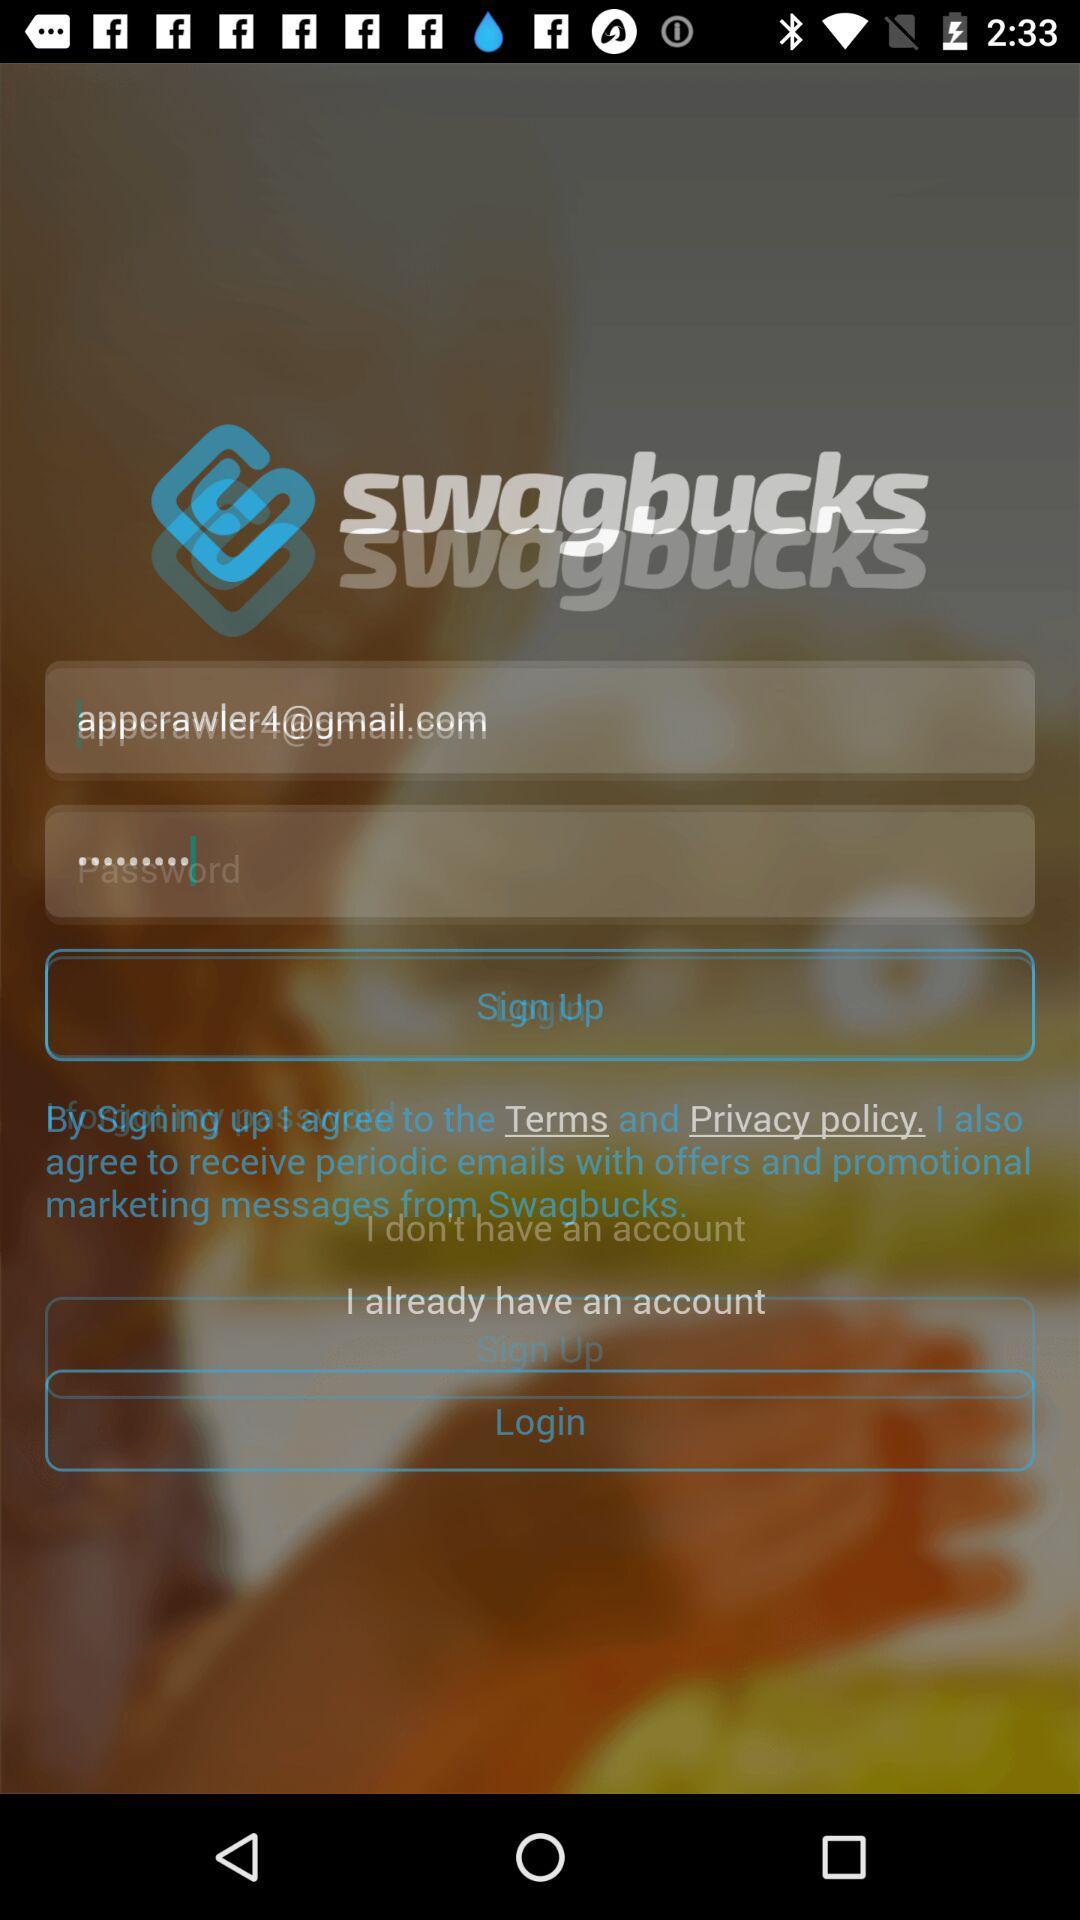What is the application name? The application name is "swagbucks". 